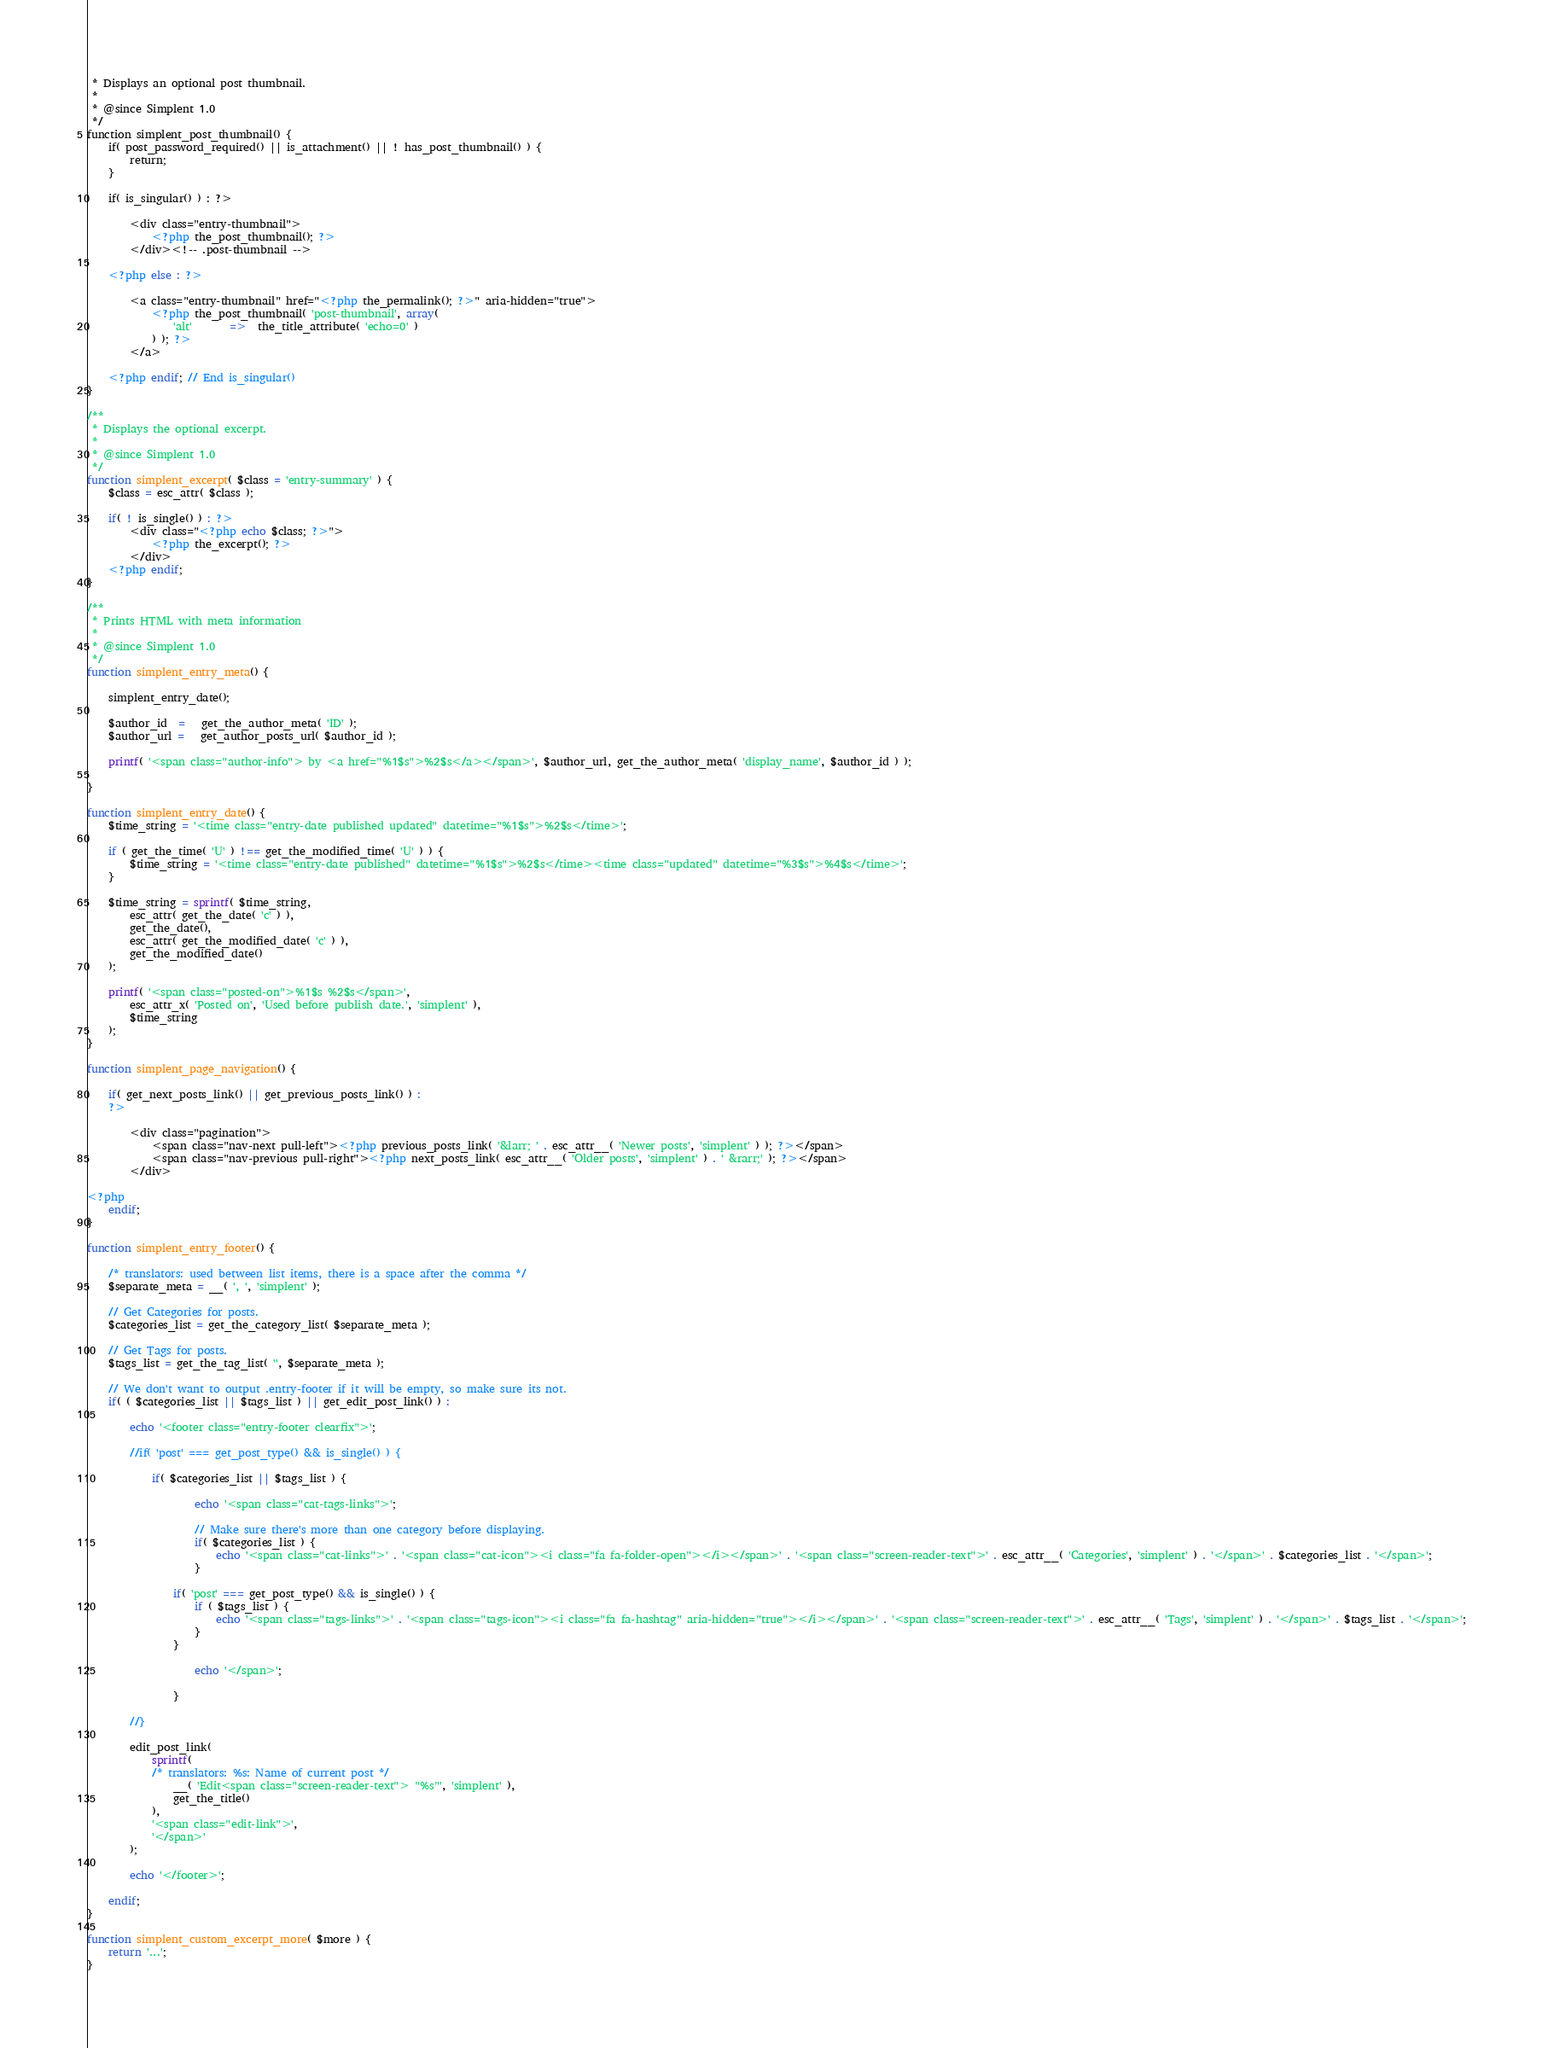Convert code to text. <code><loc_0><loc_0><loc_500><loc_500><_PHP_> * Displays an optional post thumbnail.
 *
 * @since Simplent 1.0
 */
function simplent_post_thumbnail() {
	if( post_password_required() || is_attachment() || ! has_post_thumbnail() ) {
		return;
	}

	if( is_singular() ) : ?>

		<div class="entry-thumbnail">
			<?php the_post_thumbnail(); ?>
		</div><!-- .post-thumbnail -->

	<?php else : ?>

		<a class="entry-thumbnail" href="<?php the_permalink(); ?>" aria-hidden="true">
			<?php the_post_thumbnail( 'post-thumbnail', array(
				'alt'       =>  the_title_attribute( 'echo=0' )
			) ); ?>
		</a>

	<?php endif; // End is_singular()
}

/**
 * Displays the optional excerpt.
 *
 * @since Simplent 1.0
 */
function simplent_excerpt( $class = 'entry-summary' ) {
    $class = esc_attr( $class );

    if( ! is_single() ) : ?>
        <div class="<?php echo $class; ?>">
            <?php the_excerpt(); ?>
        </div>
    <?php endif;
}

/**
 * Prints HTML with meta information
 *
 * @since Simplent 1.0
 */
function simplent_entry_meta() {

    simplent_entry_date();

    $author_id  =   get_the_author_meta( 'ID' );
    $author_url =   get_author_posts_url( $author_id );

	printf( '<span class="author-info"> by <a href="%1$s">%2$s</a></span>', $author_url, get_the_author_meta( 'display_name', $author_id ) );

}

function simplent_entry_date() {
	$time_string = '<time class="entry-date published updated" datetime="%1$s">%2$s</time>';

	if ( get_the_time( 'U' ) !== get_the_modified_time( 'U' ) ) {
		$time_string = '<time class="entry-date published" datetime="%1$s">%2$s</time><time class="updated" datetime="%3$s">%4$s</time>';
	}

	$time_string = sprintf( $time_string,
		esc_attr( get_the_date( 'c' ) ),
		get_the_date(),
		esc_attr( get_the_modified_date( 'c' ) ),
		get_the_modified_date()
	);

	printf( '<span class="posted-on">%1$s %2$s</span>',
		esc_attr_x( 'Posted on', 'Used before publish date.', 'simplent' ),
		$time_string
	);
}

function simplent_page_navigation() {

    if( get_next_posts_link() || get_previous_posts_link() ) :
    ?>

        <div class="pagination">
            <span class="nav-next pull-left"><?php previous_posts_link( '&larr; ' . esc_attr__( 'Newer posts', 'simplent' ) ); ?></span>
            <span class="nav-previous pull-right"><?php next_posts_link( esc_attr__( 'Older posts', 'simplent' ) . ' &rarr;' ); ?></span>
        </div>

<?php
    endif;
}

function simplent_entry_footer() {

	/* translators: used between list items, there is a space after the comma */
	$separate_meta = __( ', ', 'simplent' );

	// Get Categories for posts.
    $categories_list = get_the_category_list( $separate_meta );

	// Get Tags for posts.
    $tags_list = get_the_tag_list( '', $separate_meta );

	// We don't want to output .entry-footer if it will be empty, so make sure its not.
    if( ( $categories_list || $tags_list ) || get_edit_post_link() ) :

        echo '<footer class="entry-footer clearfix">';

        //if( 'post' === get_post_type() && is_single() ) {

            if( $categories_list || $tags_list ) {

                    echo '<span class="cat-tags-links">';

	                // Make sure there's more than one category before displaying.
                    if( $categories_list ) {
                        echo '<span class="cat-links">' . '<span class="cat-icon"><i class="fa fa-folder-open"></i></span>' . '<span class="screen-reader-text">' . esc_attr__( 'Categories', 'simplent' ) . '</span>' . $categories_list . '</span>';
                    }

	            if( 'post' === get_post_type() && is_single() ) {
		            if ( $tags_list ) {
			            echo '<span class="tags-links">' . '<span class="tags-icon"><i class="fa fa-hashtag" aria-hidden="true"></i></span>' . '<span class="screen-reader-text">' . esc_attr__( 'Tags', 'simplent' ) . '</span>' . $tags_list . '</span>';
		            }
	            }

                    echo '</span>';

                }

        //}

	    edit_post_link(
		    sprintf(
		    /* translators: %s: Name of current post */
			    __( 'Edit<span class="screen-reader-text"> "%s"', 'simplent' ),
			    get_the_title()
		    ),
		    '<span class="edit-link">',
		    '</span>'
	    );

        echo '</footer>';

    endif;
}

function simplent_custom_excerpt_more( $more ) {
	return '...';
}</code> 